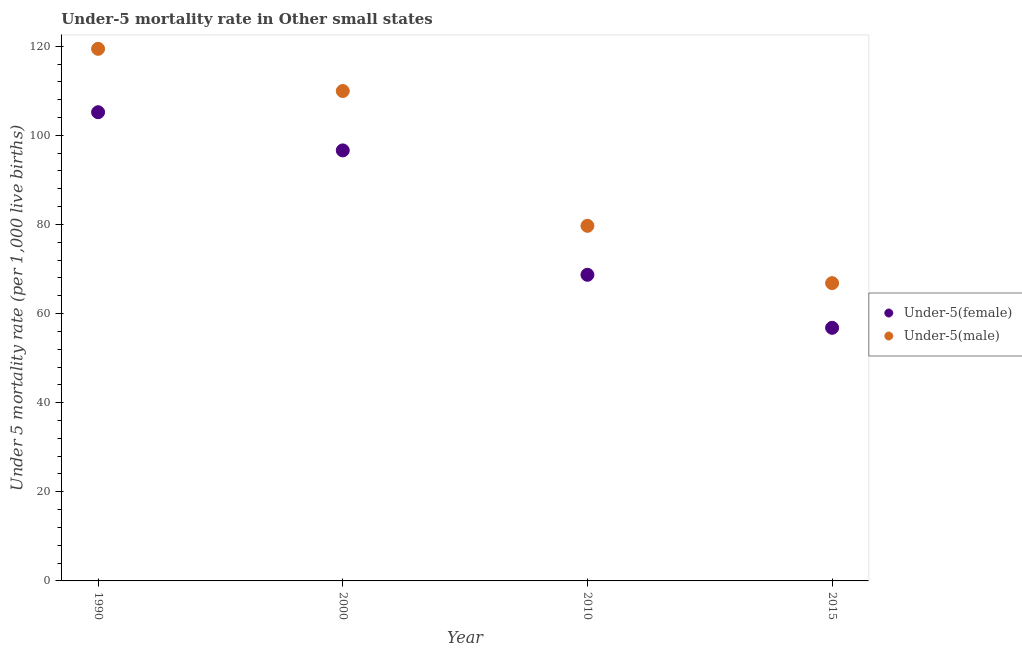How many different coloured dotlines are there?
Your answer should be very brief. 2. What is the under-5 female mortality rate in 2015?
Provide a short and direct response. 56.81. Across all years, what is the maximum under-5 male mortality rate?
Ensure brevity in your answer.  119.42. Across all years, what is the minimum under-5 female mortality rate?
Provide a succinct answer. 56.81. In which year was the under-5 male mortality rate maximum?
Provide a succinct answer. 1990. In which year was the under-5 male mortality rate minimum?
Provide a short and direct response. 2015. What is the total under-5 female mortality rate in the graph?
Provide a succinct answer. 327.33. What is the difference between the under-5 female mortality rate in 2000 and that in 2010?
Offer a very short reply. 27.92. What is the difference between the under-5 female mortality rate in 2010 and the under-5 male mortality rate in 2000?
Keep it short and to the point. -41.25. What is the average under-5 female mortality rate per year?
Make the answer very short. 81.83. In the year 2015, what is the difference between the under-5 male mortality rate and under-5 female mortality rate?
Provide a short and direct response. 10.03. In how many years, is the under-5 female mortality rate greater than 8?
Offer a very short reply. 4. What is the ratio of the under-5 male mortality rate in 1990 to that in 2010?
Provide a short and direct response. 1.5. Is the difference between the under-5 female mortality rate in 1990 and 2015 greater than the difference between the under-5 male mortality rate in 1990 and 2015?
Offer a terse response. No. What is the difference between the highest and the second highest under-5 female mortality rate?
Offer a very short reply. 8.57. What is the difference between the highest and the lowest under-5 female mortality rate?
Offer a terse response. 48.38. In how many years, is the under-5 male mortality rate greater than the average under-5 male mortality rate taken over all years?
Your answer should be compact. 2. Is the under-5 female mortality rate strictly less than the under-5 male mortality rate over the years?
Provide a succinct answer. Yes. How many dotlines are there?
Make the answer very short. 2. How many years are there in the graph?
Offer a very short reply. 4. What is the difference between two consecutive major ticks on the Y-axis?
Keep it short and to the point. 20. How are the legend labels stacked?
Offer a terse response. Vertical. What is the title of the graph?
Your response must be concise. Under-5 mortality rate in Other small states. What is the label or title of the X-axis?
Offer a very short reply. Year. What is the label or title of the Y-axis?
Provide a succinct answer. Under 5 mortality rate (per 1,0 live births). What is the Under 5 mortality rate (per 1,000 live births) in Under-5(female) in 1990?
Offer a terse response. 105.19. What is the Under 5 mortality rate (per 1,000 live births) of Under-5(male) in 1990?
Make the answer very short. 119.42. What is the Under 5 mortality rate (per 1,000 live births) of Under-5(female) in 2000?
Keep it short and to the point. 96.62. What is the Under 5 mortality rate (per 1,000 live births) in Under-5(male) in 2000?
Offer a terse response. 109.95. What is the Under 5 mortality rate (per 1,000 live births) in Under-5(female) in 2010?
Offer a terse response. 68.7. What is the Under 5 mortality rate (per 1,000 live births) in Under-5(male) in 2010?
Your answer should be very brief. 79.69. What is the Under 5 mortality rate (per 1,000 live births) in Under-5(female) in 2015?
Your response must be concise. 56.81. What is the Under 5 mortality rate (per 1,000 live births) of Under-5(male) in 2015?
Your answer should be very brief. 66.83. Across all years, what is the maximum Under 5 mortality rate (per 1,000 live births) of Under-5(female)?
Provide a short and direct response. 105.19. Across all years, what is the maximum Under 5 mortality rate (per 1,000 live births) of Under-5(male)?
Provide a succinct answer. 119.42. Across all years, what is the minimum Under 5 mortality rate (per 1,000 live births) in Under-5(female)?
Keep it short and to the point. 56.81. Across all years, what is the minimum Under 5 mortality rate (per 1,000 live births) in Under-5(male)?
Give a very brief answer. 66.83. What is the total Under 5 mortality rate (per 1,000 live births) in Under-5(female) in the graph?
Provide a short and direct response. 327.33. What is the total Under 5 mortality rate (per 1,000 live births) of Under-5(male) in the graph?
Provide a succinct answer. 375.9. What is the difference between the Under 5 mortality rate (per 1,000 live births) of Under-5(female) in 1990 and that in 2000?
Your answer should be compact. 8.57. What is the difference between the Under 5 mortality rate (per 1,000 live births) in Under-5(male) in 1990 and that in 2000?
Give a very brief answer. 9.47. What is the difference between the Under 5 mortality rate (per 1,000 live births) of Under-5(female) in 1990 and that in 2010?
Give a very brief answer. 36.49. What is the difference between the Under 5 mortality rate (per 1,000 live births) of Under-5(male) in 1990 and that in 2010?
Keep it short and to the point. 39.73. What is the difference between the Under 5 mortality rate (per 1,000 live births) in Under-5(female) in 1990 and that in 2015?
Provide a succinct answer. 48.38. What is the difference between the Under 5 mortality rate (per 1,000 live births) of Under-5(male) in 1990 and that in 2015?
Your answer should be compact. 52.59. What is the difference between the Under 5 mortality rate (per 1,000 live births) in Under-5(female) in 2000 and that in 2010?
Give a very brief answer. 27.92. What is the difference between the Under 5 mortality rate (per 1,000 live births) of Under-5(male) in 2000 and that in 2010?
Offer a terse response. 30.26. What is the difference between the Under 5 mortality rate (per 1,000 live births) in Under-5(female) in 2000 and that in 2015?
Keep it short and to the point. 39.82. What is the difference between the Under 5 mortality rate (per 1,000 live births) of Under-5(male) in 2000 and that in 2015?
Your response must be concise. 43.12. What is the difference between the Under 5 mortality rate (per 1,000 live births) in Under-5(female) in 2010 and that in 2015?
Your answer should be very brief. 11.9. What is the difference between the Under 5 mortality rate (per 1,000 live births) in Under-5(male) in 2010 and that in 2015?
Provide a succinct answer. 12.86. What is the difference between the Under 5 mortality rate (per 1,000 live births) in Under-5(female) in 1990 and the Under 5 mortality rate (per 1,000 live births) in Under-5(male) in 2000?
Provide a succinct answer. -4.76. What is the difference between the Under 5 mortality rate (per 1,000 live births) of Under-5(female) in 1990 and the Under 5 mortality rate (per 1,000 live births) of Under-5(male) in 2010?
Make the answer very short. 25.5. What is the difference between the Under 5 mortality rate (per 1,000 live births) of Under-5(female) in 1990 and the Under 5 mortality rate (per 1,000 live births) of Under-5(male) in 2015?
Offer a very short reply. 38.36. What is the difference between the Under 5 mortality rate (per 1,000 live births) in Under-5(female) in 2000 and the Under 5 mortality rate (per 1,000 live births) in Under-5(male) in 2010?
Offer a terse response. 16.93. What is the difference between the Under 5 mortality rate (per 1,000 live births) of Under-5(female) in 2000 and the Under 5 mortality rate (per 1,000 live births) of Under-5(male) in 2015?
Keep it short and to the point. 29.79. What is the difference between the Under 5 mortality rate (per 1,000 live births) of Under-5(female) in 2010 and the Under 5 mortality rate (per 1,000 live births) of Under-5(male) in 2015?
Offer a very short reply. 1.87. What is the average Under 5 mortality rate (per 1,000 live births) of Under-5(female) per year?
Give a very brief answer. 81.83. What is the average Under 5 mortality rate (per 1,000 live births) in Under-5(male) per year?
Provide a succinct answer. 93.97. In the year 1990, what is the difference between the Under 5 mortality rate (per 1,000 live births) of Under-5(female) and Under 5 mortality rate (per 1,000 live births) of Under-5(male)?
Ensure brevity in your answer.  -14.23. In the year 2000, what is the difference between the Under 5 mortality rate (per 1,000 live births) of Under-5(female) and Under 5 mortality rate (per 1,000 live births) of Under-5(male)?
Offer a terse response. -13.33. In the year 2010, what is the difference between the Under 5 mortality rate (per 1,000 live births) in Under-5(female) and Under 5 mortality rate (per 1,000 live births) in Under-5(male)?
Your response must be concise. -10.99. In the year 2015, what is the difference between the Under 5 mortality rate (per 1,000 live births) of Under-5(female) and Under 5 mortality rate (per 1,000 live births) of Under-5(male)?
Provide a succinct answer. -10.03. What is the ratio of the Under 5 mortality rate (per 1,000 live births) in Under-5(female) in 1990 to that in 2000?
Offer a very short reply. 1.09. What is the ratio of the Under 5 mortality rate (per 1,000 live births) in Under-5(male) in 1990 to that in 2000?
Offer a very short reply. 1.09. What is the ratio of the Under 5 mortality rate (per 1,000 live births) of Under-5(female) in 1990 to that in 2010?
Make the answer very short. 1.53. What is the ratio of the Under 5 mortality rate (per 1,000 live births) in Under-5(male) in 1990 to that in 2010?
Your answer should be compact. 1.5. What is the ratio of the Under 5 mortality rate (per 1,000 live births) of Under-5(female) in 1990 to that in 2015?
Your answer should be very brief. 1.85. What is the ratio of the Under 5 mortality rate (per 1,000 live births) in Under-5(male) in 1990 to that in 2015?
Your answer should be compact. 1.79. What is the ratio of the Under 5 mortality rate (per 1,000 live births) of Under-5(female) in 2000 to that in 2010?
Your answer should be compact. 1.41. What is the ratio of the Under 5 mortality rate (per 1,000 live births) in Under-5(male) in 2000 to that in 2010?
Make the answer very short. 1.38. What is the ratio of the Under 5 mortality rate (per 1,000 live births) in Under-5(female) in 2000 to that in 2015?
Ensure brevity in your answer.  1.7. What is the ratio of the Under 5 mortality rate (per 1,000 live births) of Under-5(male) in 2000 to that in 2015?
Your response must be concise. 1.65. What is the ratio of the Under 5 mortality rate (per 1,000 live births) in Under-5(female) in 2010 to that in 2015?
Keep it short and to the point. 1.21. What is the ratio of the Under 5 mortality rate (per 1,000 live births) in Under-5(male) in 2010 to that in 2015?
Offer a very short reply. 1.19. What is the difference between the highest and the second highest Under 5 mortality rate (per 1,000 live births) of Under-5(female)?
Your response must be concise. 8.57. What is the difference between the highest and the second highest Under 5 mortality rate (per 1,000 live births) in Under-5(male)?
Your response must be concise. 9.47. What is the difference between the highest and the lowest Under 5 mortality rate (per 1,000 live births) in Under-5(female)?
Ensure brevity in your answer.  48.38. What is the difference between the highest and the lowest Under 5 mortality rate (per 1,000 live births) of Under-5(male)?
Your response must be concise. 52.59. 